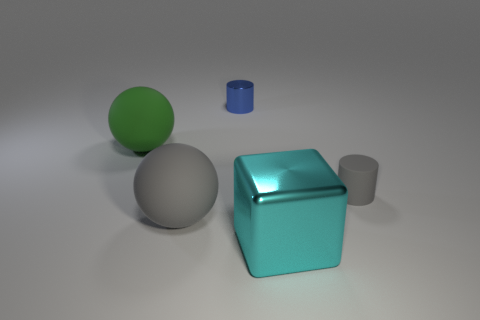What can you infer about the texture of the objects? The objects appear to have a smooth texture, as evidenced by the clear reflections and the lack of visible texture marks or grain. The smoothness contributes to the shiny, reflective quality observed on their surfaces. 